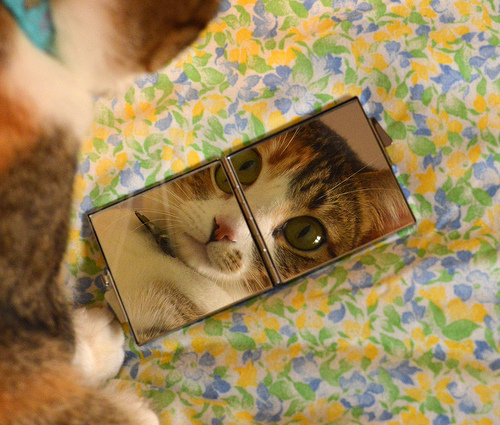<image>
Is the phone on the bed? Yes. Looking at the image, I can see the phone is positioned on top of the bed, with the bed providing support. 